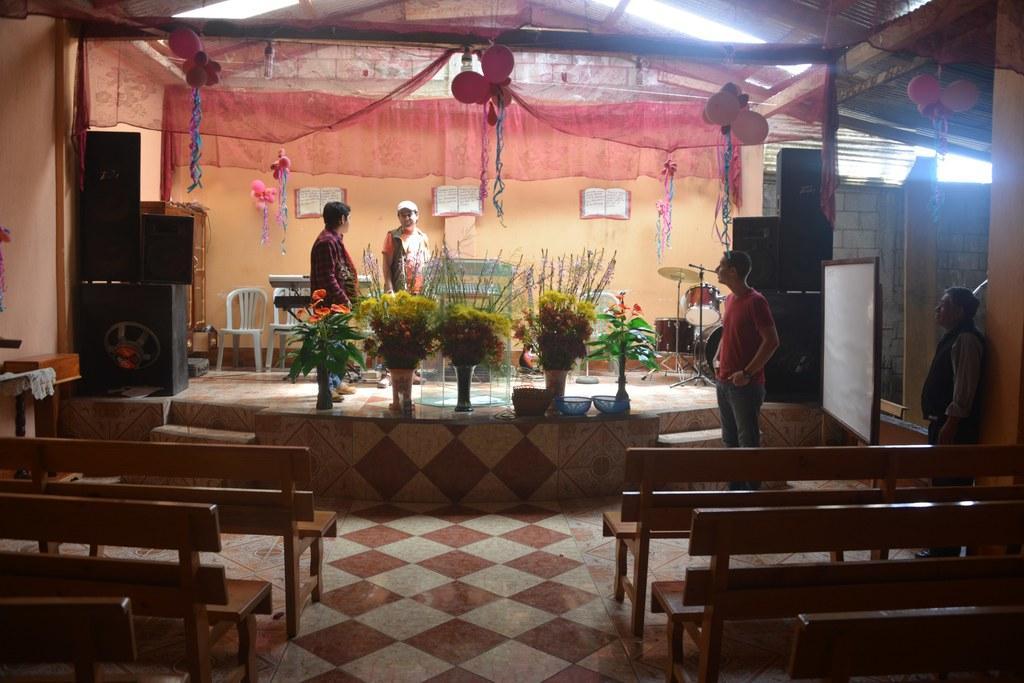Describe this image in one or two sentences. In the picture I can see flower bouquets, benches, people among them some are standing on the floor and some are standing on stage. I can also see sound speaker, balloons, chairs and some other objects. 